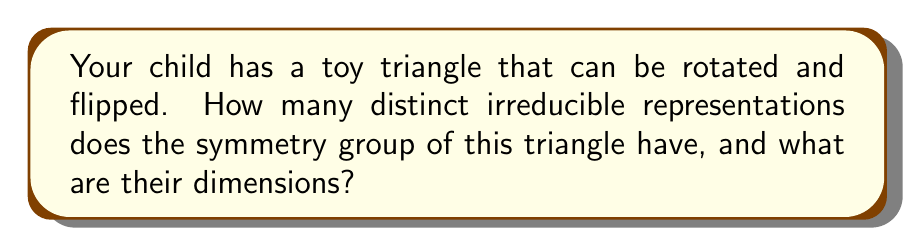Solve this math problem. Let's approach this step-by-step:

1) First, we need to identify the symmetry group of a triangle. This is the dihedral group $D_3$, which has 6 elements:
   - 3 rotations (0°, 120°, 240°)
   - 3 reflections (across each altitude)

2) To find the irreducible representations, we use the formula:
   $$ \sum_{i=1}^{k} n_i^2 = |G| $$
   where $k$ is the number of irreducible representations, $n_i$ is the dimension of the $i$-th representation, and $|G|$ is the order of the group (6 in this case).

3) For $D_3$, we know there are always two 1-dimensional representations:
   - The trivial representation
   - The sign representation

4) Let's call the dimension of the remaining representation $n$. We can set up the equation:
   $$ 1^2 + 1^2 + n^2 = 6 $$

5) Solving for $n$:
   $$ n^2 = 6 - 2 = 4 $$
   $$ n = 2 $$

6) Therefore, the irreducible representations of $D_3$ are:
   - Two 1-dimensional representations
   - One 2-dimensional representation

In total, there are 3 distinct irreducible representations.
Answer: 3 irreducible representations: two 1-dimensional and one 2-dimensional 